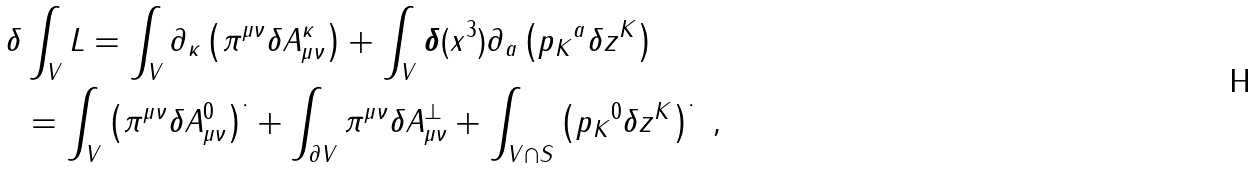<formula> <loc_0><loc_0><loc_500><loc_500>\delta & \int _ { V } L = \int _ { V } \partial _ { \kappa } \left ( \pi ^ { \mu \nu } \delta A ^ { \kappa } _ { \mu \nu } \right ) + \int _ { V } \boldsymbol \delta ( x ^ { 3 } ) \partial _ { a } \left ( { p _ { K } } ^ { a } \delta z ^ { K } \right ) \\ & = \int _ { V } \left ( \pi ^ { \mu \nu } \delta A ^ { 0 } _ { \mu \nu } \right ) ^ { \cdot } + \int _ { \partial V } \pi ^ { \mu \nu } \delta A ^ { \perp } _ { \mu \nu } + \int _ { V \cap S } \left ( { p _ { K } } ^ { 0 } \delta z ^ { K } \right ) ^ { \cdot } \ ,</formula> 